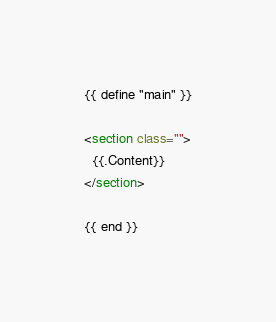Convert code to text. <code><loc_0><loc_0><loc_500><loc_500><_HTML_>{{ define "main" }}

<section class="">
  {{.Content}}
</section>

{{ end }}
</code> 